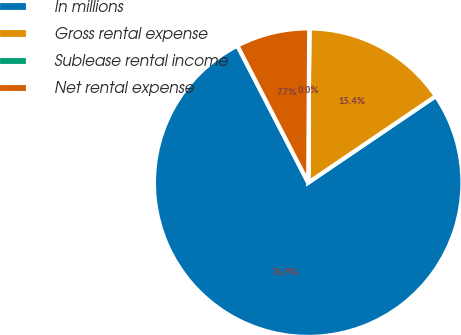<chart> <loc_0><loc_0><loc_500><loc_500><pie_chart><fcel>In millions<fcel>Gross rental expense<fcel>Sublease rental income<fcel>Net rental expense<nl><fcel>76.89%<fcel>15.39%<fcel>0.02%<fcel>7.7%<nl></chart> 